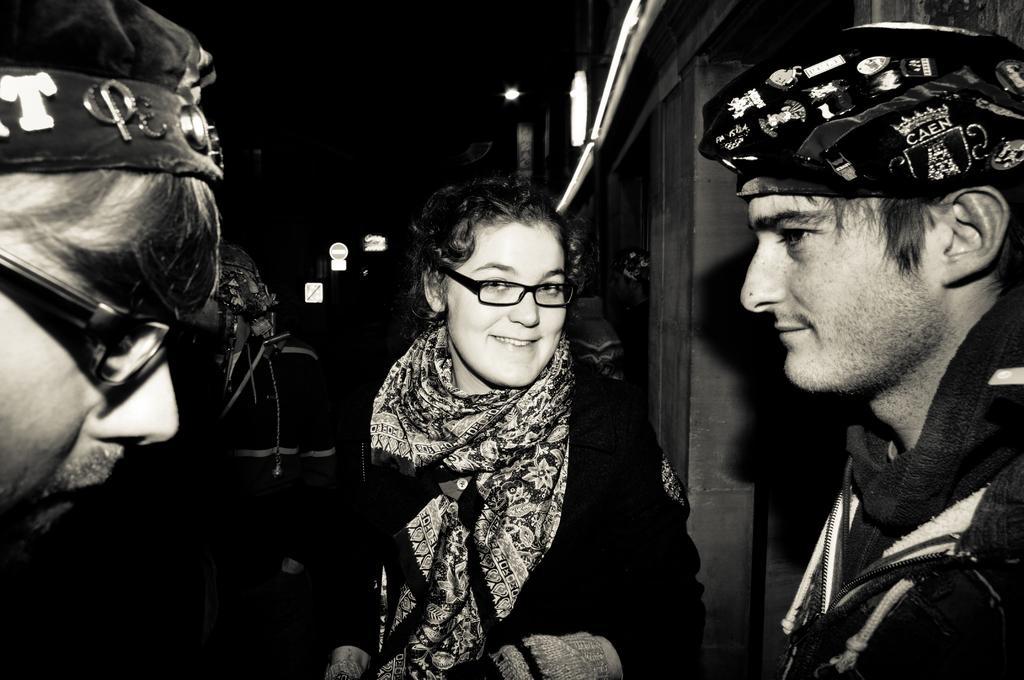Describe this image in one or two sentences. In this image I can see three people with the dresses. I can see two people are wearing the caps and also two people are wearing the specs. To the right there is a building. In the background I can see some lights and this is a black and white image. 